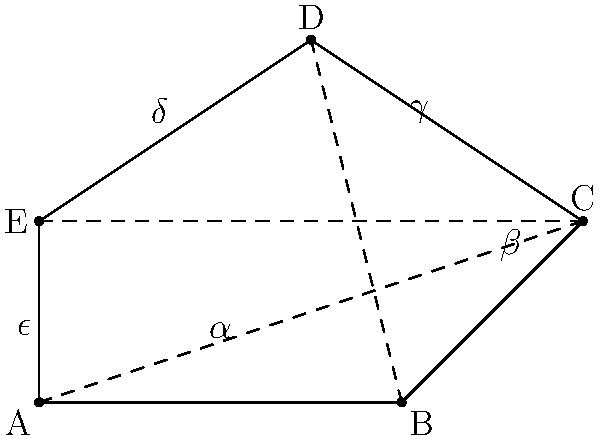In the latest cliffhanger episode of "Passionate Hearts," the mysterious villain presents a pentagonal engagement ring box to the unsuspecting heroine. The interior angles of this pentagon are labeled $\alpha$, $\beta$, $\gamma$, $\delta$, and $\epsilon$. If $\alpha = 108°$, $\beta = 112°$, $\gamma = 110°$, and $\delta = 115°$, what is the measure of angle $\epsilon$? Let's approach this step-by-step:

1) First, recall that the sum of interior angles of a pentagon is given by the formula:
   $$(n-2) \times 180°$$
   where $n$ is the number of sides.

2) For a pentagon, $n = 5$, so the sum of interior angles is:
   $$(5-2) \times 180° = 3 \times 180° = 540°$$

3) We know four of the five angles:
   $\alpha = 108°$
   $\beta = 112°$
   $\gamma = 110°$
   $\delta = 115°$

4) Let's add these known angles:
   $$108° + 112° + 110° + 115° = 445°$$

5) The remaining angle, $\epsilon$, must make up the difference to reach 540°:
   $$\epsilon = 540° - 445° = 95°$$

Therefore, the measure of angle $\epsilon$ is 95°.
Answer: 95° 